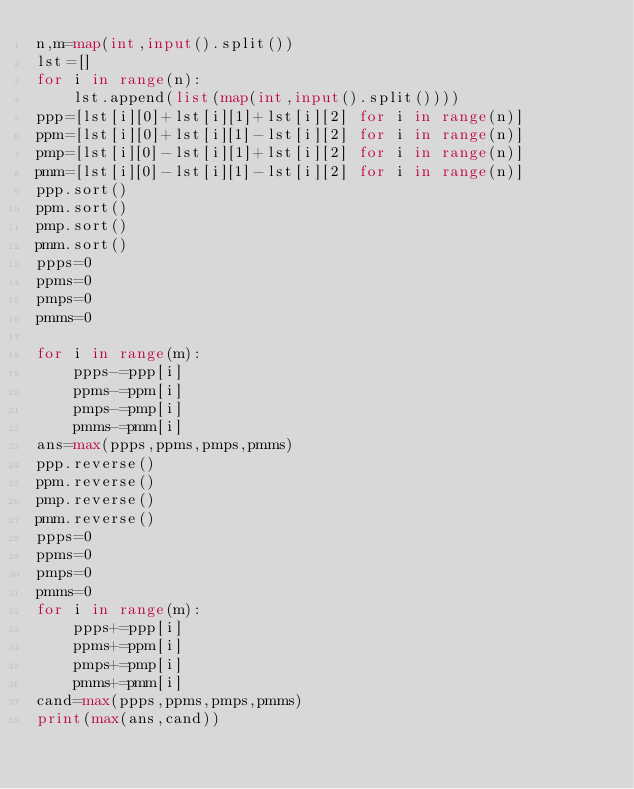<code> <loc_0><loc_0><loc_500><loc_500><_Python_>n,m=map(int,input().split())
lst=[]
for i in range(n):
    lst.append(list(map(int,input().split())))
ppp=[lst[i][0]+lst[i][1]+lst[i][2] for i in range(n)]
ppm=[lst[i][0]+lst[i][1]-lst[i][2] for i in range(n)]
pmp=[lst[i][0]-lst[i][1]+lst[i][2] for i in range(n)]
pmm=[lst[i][0]-lst[i][1]-lst[i][2] for i in range(n)]
ppp.sort()
ppm.sort()
pmp.sort()
pmm.sort()
ppps=0
ppms=0
pmps=0
pmms=0

for i in range(m):
    ppps-=ppp[i]
    ppms-=ppm[i]
    pmps-=pmp[i]
    pmms-=pmm[i]
ans=max(ppps,ppms,pmps,pmms)
ppp.reverse()
ppm.reverse()
pmp.reverse()
pmm.reverse()
ppps=0
ppms=0
pmps=0
pmms=0
for i in range(m):
    ppps+=ppp[i]
    ppms+=ppm[i]
    pmps+=pmp[i]
    pmms+=pmm[i]
cand=max(ppps,ppms,pmps,pmms)
print(max(ans,cand))</code> 